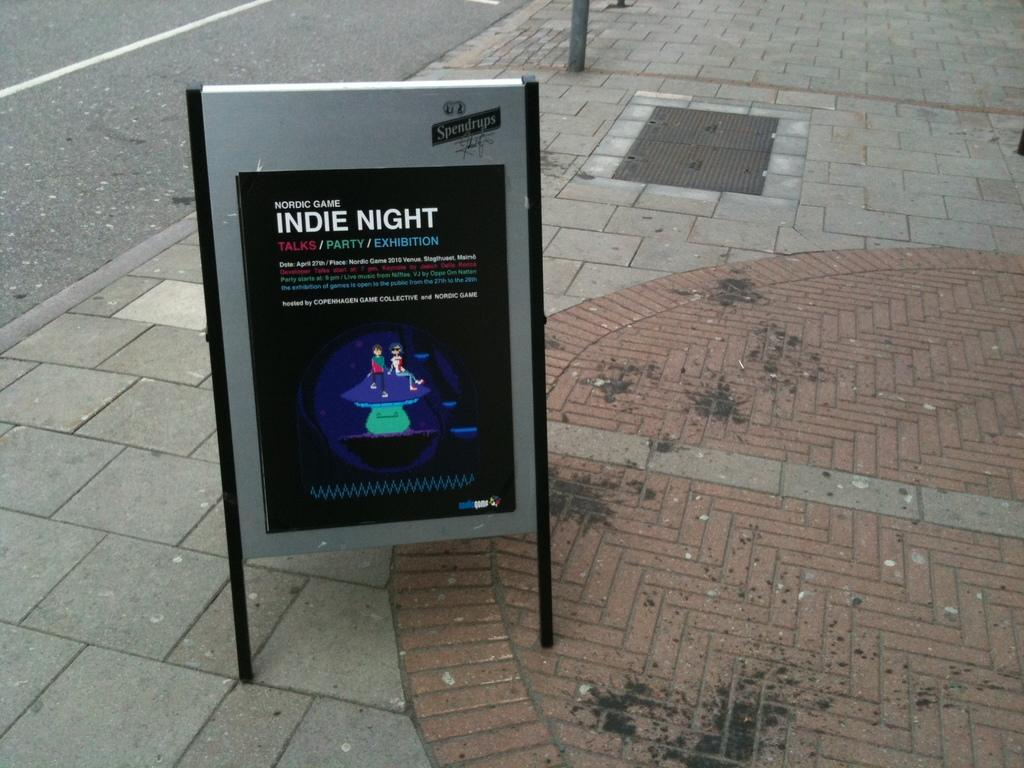<image>
Write a terse but informative summary of the picture. A sign on a pavement which is advertising an Indie Night. 